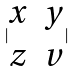<formula> <loc_0><loc_0><loc_500><loc_500>| \begin{matrix} x & y \\ z & v \end{matrix} |</formula> 